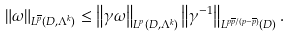<formula> <loc_0><loc_0><loc_500><loc_500>\left \| \omega \right \| _ { L ^ { \overline { p } } ( D , \Lambda ^ { k } ) } \leq \left \| \gamma \omega \right \| _ { L ^ { p } ( D , \Lambda ^ { k } ) } \left \| \gamma ^ { - 1 } \right \| _ { L ^ { p \overline { p } / ( p - \overline { p } ) } ( D ) } .</formula> 